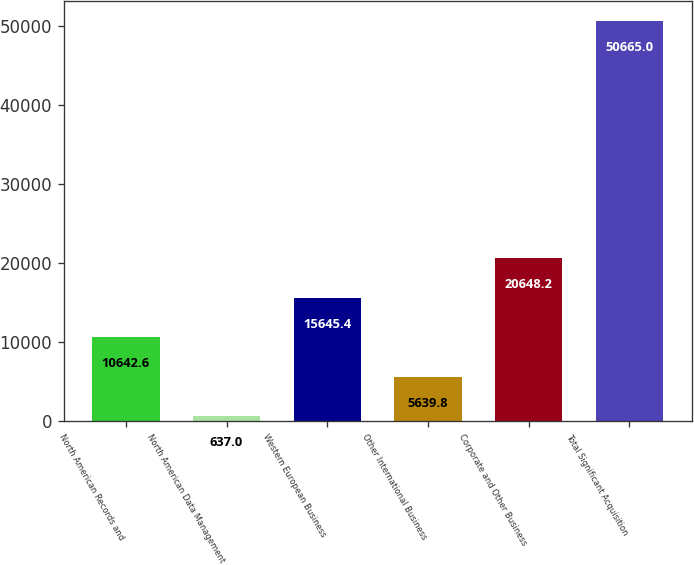Convert chart to OTSL. <chart><loc_0><loc_0><loc_500><loc_500><bar_chart><fcel>North American Records and<fcel>North American Data Management<fcel>Western European Business<fcel>Other International Business<fcel>Corporate and Other Business<fcel>Total Significant Acquisition<nl><fcel>10642.6<fcel>637<fcel>15645.4<fcel>5639.8<fcel>20648.2<fcel>50665<nl></chart> 